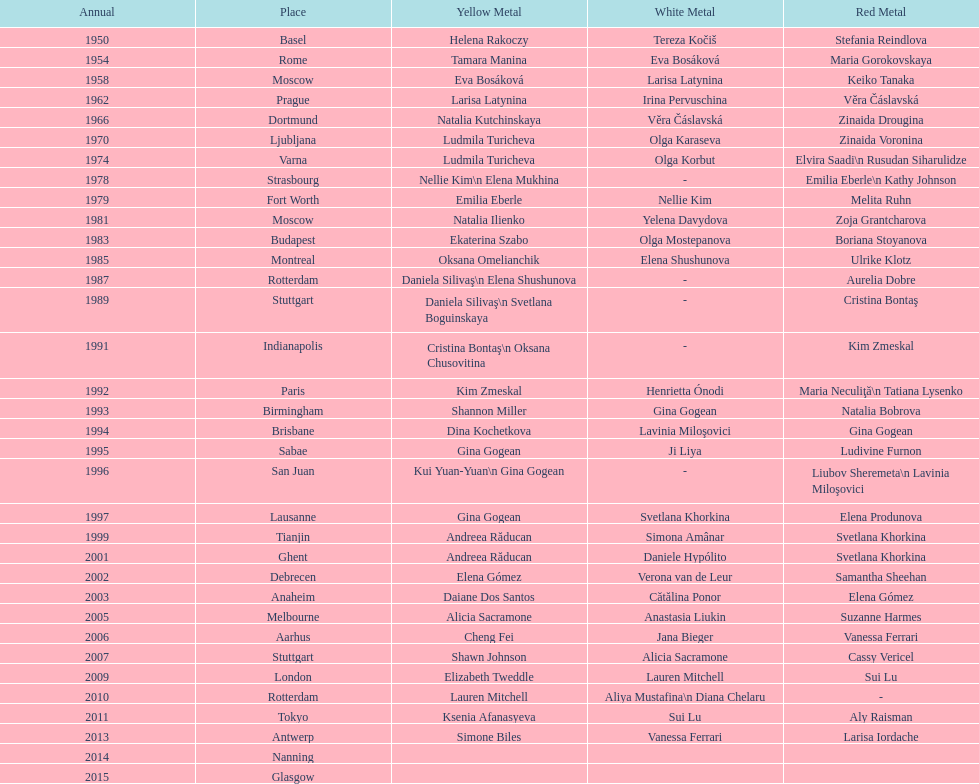Where did the world artistic gymnastics take place before san juan? Sabae. 